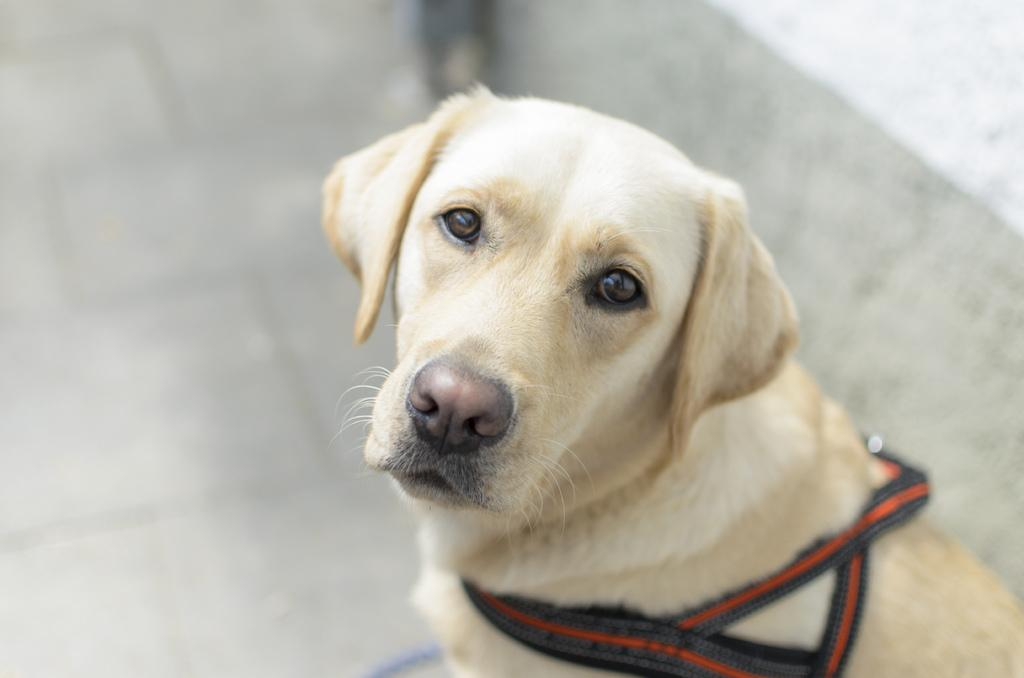What animal is present in the image? There is a dog in the picture. What is the dog doing in the image? The dog is sitting. What color is the dog's fur? The dog has cream-colored fur. Is there any accessory or object around the dog's neck? Yes, the dog has a belt around its neck. Can you describe the background of the image? The backdrop of the image is blurred. How many spiders are crawling on the dog in the image? There are no spiders present in the image; it features a dog with a belt around its neck. What type of pencil is the dog holding in the image? There is no pencil present in the image, and the dog is not holding anything. 